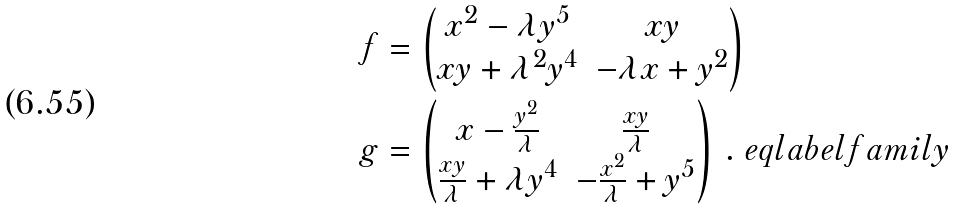Convert formula to latex. <formula><loc_0><loc_0><loc_500><loc_500>f & = \begin{pmatrix} x ^ { 2 } - \lambda y ^ { 5 } & x y \\ x y + \lambda ^ { 2 } y ^ { 4 } & - \lambda x + y ^ { 2 } \end{pmatrix} \\ g & = \begin{pmatrix} x - \frac { y ^ { 2 } } \lambda & \frac { x y } { \lambda } \\ \frac { x y } { \lambda } + \lambda y ^ { 4 } & - \frac { x ^ { 2 } } { \lambda } + y ^ { 5 } \end{pmatrix} \, . \ e q l a b e l { f a m i l y }</formula> 